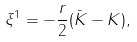Convert formula to latex. <formula><loc_0><loc_0><loc_500><loc_500>\xi ^ { 1 } = - \frac { r } { 2 } ( { \bar { K } } - K ) ,</formula> 